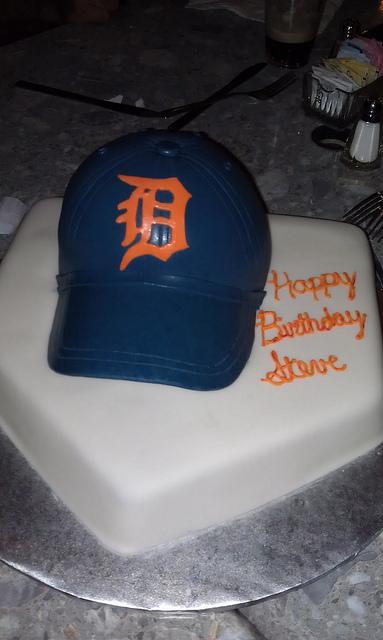What team is this for?
Quick response, please. Detroit. What does the cake say?
Keep it brief. Happy birthday steve. Whose birthday is it?
Give a very brief answer. Steve. 